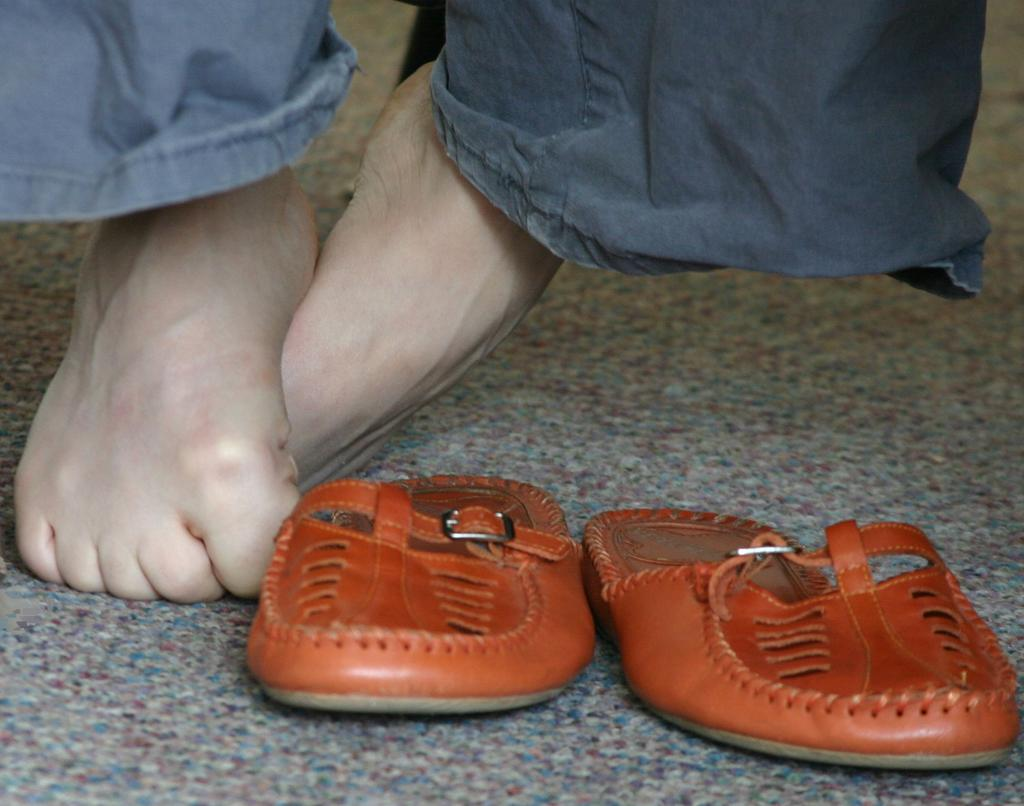What part of a person can be seen in the image? There are legs of a person in the image. What type of footwear is the person wearing? The person is wearing brown-colored slippers. How many sheep are visible in the image? There are no sheep present in the image. What type of yoke is being used by the person in the image? There is no yoke present in the image. 